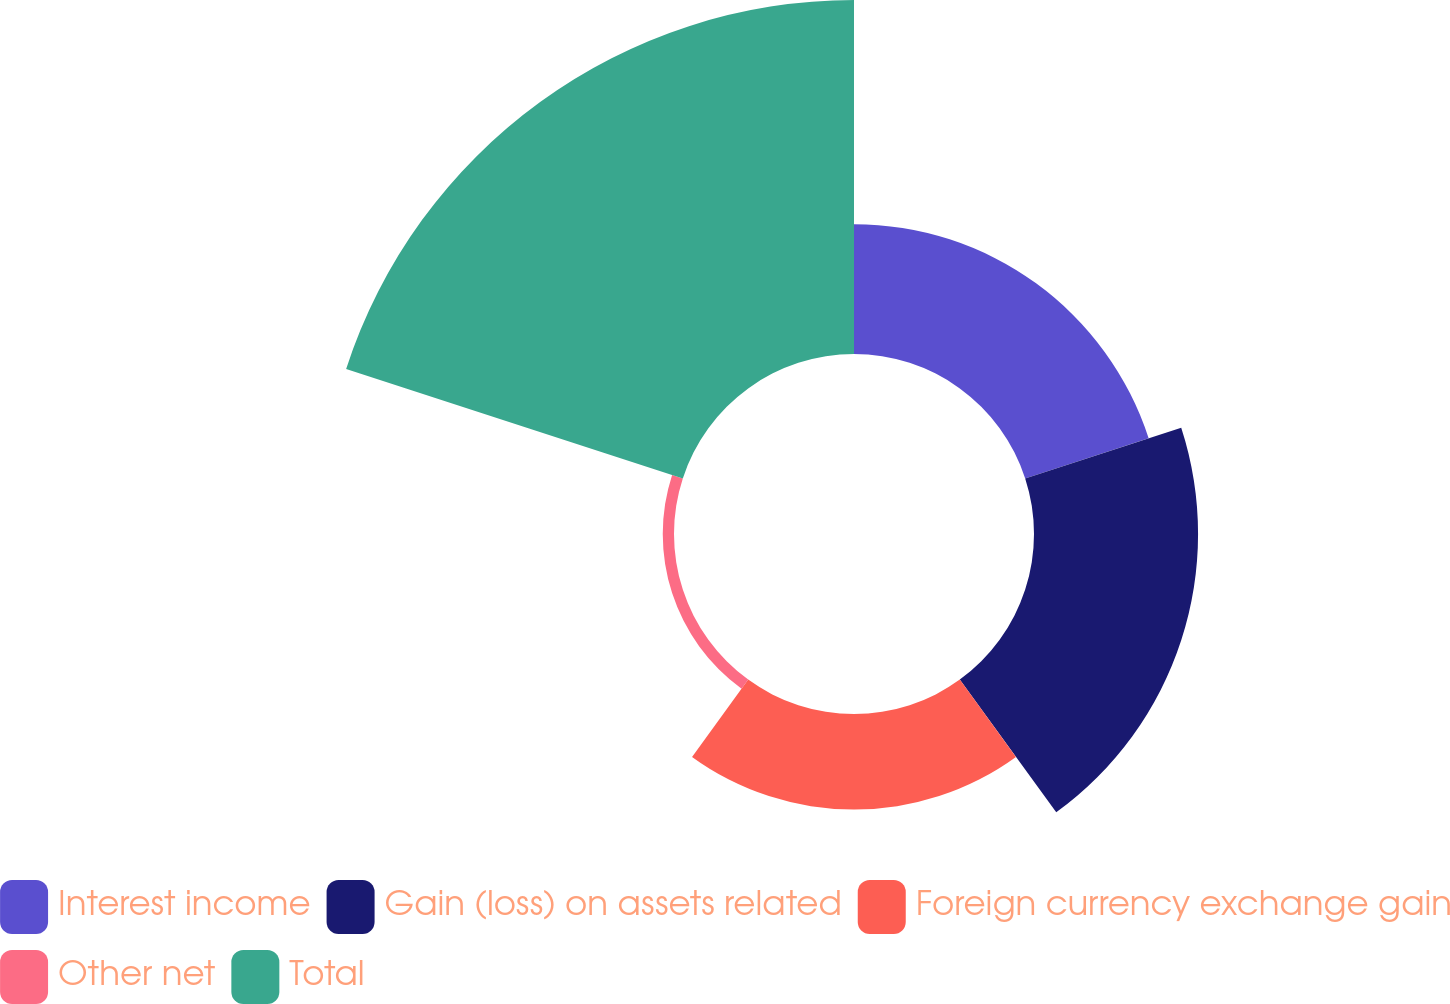Convert chart to OTSL. <chart><loc_0><loc_0><loc_500><loc_500><pie_chart><fcel>Interest income<fcel>Gain (loss) on assets related<fcel>Foreign currency exchange gain<fcel>Other net<fcel>Total<nl><fcel>17.2%<fcel>21.74%<fcel>12.66%<fcel>1.49%<fcel>46.91%<nl></chart> 